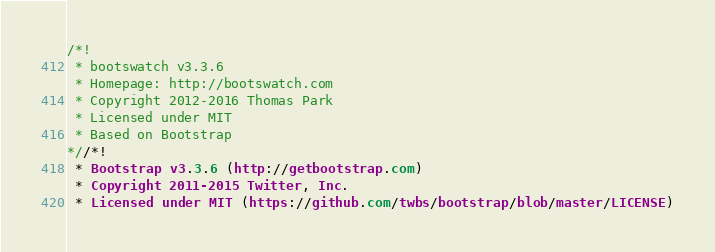Convert code to text. <code><loc_0><loc_0><loc_500><loc_500><_CSS_>/*!
 * bootswatch v3.3.6
 * Homepage: http://bootswatch.com
 * Copyright 2012-2016 Thomas Park
 * Licensed under MIT
 * Based on Bootstrap
*//*!
 * Bootstrap v3.3.6 (http://getbootstrap.com)
 * Copyright 2011-2015 Twitter, Inc.
 * Licensed under MIT (https://github.com/twbs/bootstrap/blob/master/LICENSE)</code> 